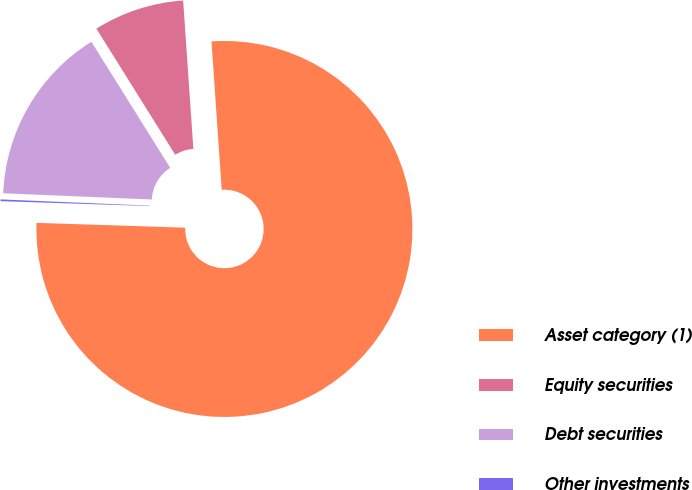Convert chart. <chart><loc_0><loc_0><loc_500><loc_500><pie_chart><fcel>Asset category (1)<fcel>Equity securities<fcel>Debt securities<fcel>Other investments<nl><fcel>76.61%<fcel>7.8%<fcel>15.44%<fcel>0.15%<nl></chart> 